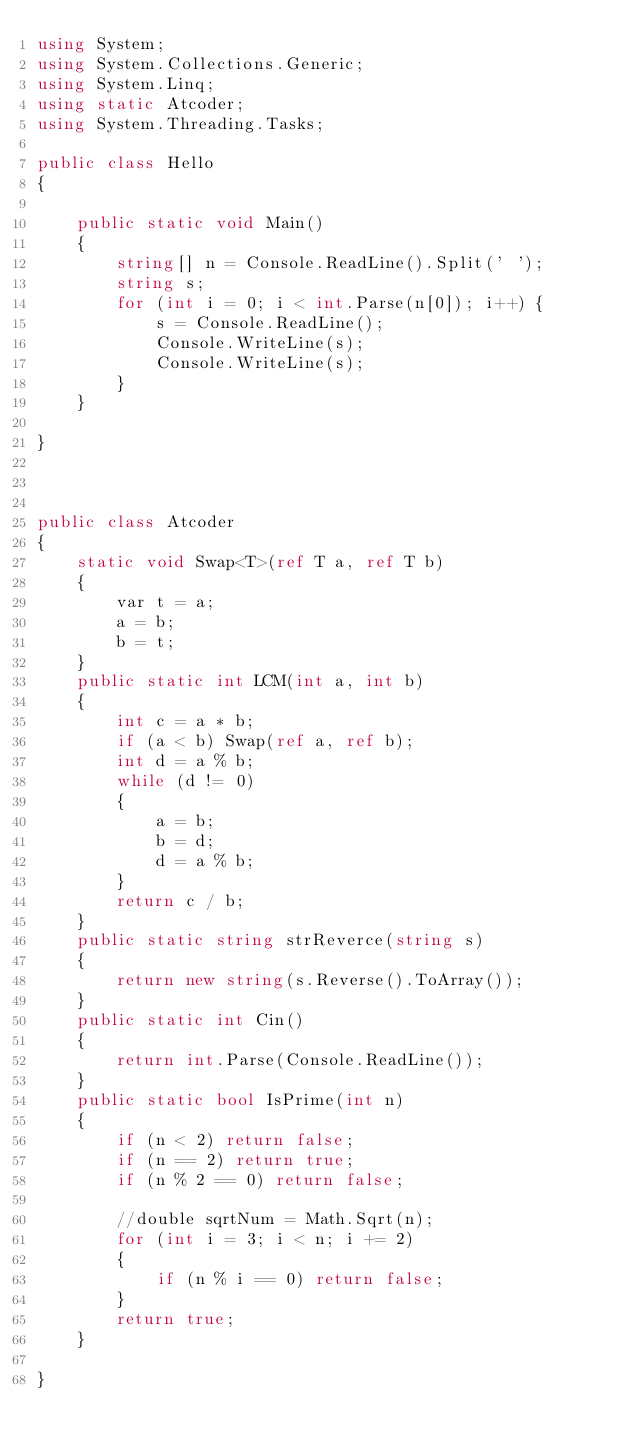<code> <loc_0><loc_0><loc_500><loc_500><_C#_>using System;
using System.Collections.Generic;
using System.Linq;
using static Atcoder;
using System.Threading.Tasks;

public class Hello
{

    public static void Main()
    {
        string[] n = Console.ReadLine().Split(' ');
        string s;
        for (int i = 0; i < int.Parse(n[0]); i++) {
            s = Console.ReadLine();
            Console.WriteLine(s);
            Console.WriteLine(s);
        }
    }

}



public class Atcoder
{
    static void Swap<T>(ref T a, ref T b)
    {
        var t = a;
        a = b;
        b = t;
    }
    public static int LCM(int a, int b)
    {
        int c = a * b;
        if (a < b) Swap(ref a, ref b);
        int d = a % b;
        while (d != 0)
        {
            a = b;
            b = d;
            d = a % b;
        }
        return c / b;
    }
    public static string strReverce(string s)
    {
        return new string(s.Reverse().ToArray());
    }
    public static int Cin()
    {
        return int.Parse(Console.ReadLine());
    }
    public static bool IsPrime(int n)
    {
        if (n < 2) return false;
        if (n == 2) return true;
        if (n % 2 == 0) return false;

        //double sqrtNum = Math.Sqrt(n);
        for (int i = 3; i < n; i += 2)
        {
            if (n % i == 0) return false;
        }
        return true;
    }

}
</code> 